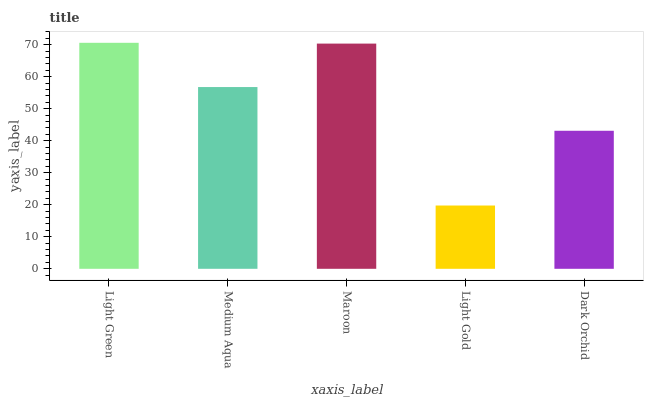Is Light Gold the minimum?
Answer yes or no. Yes. Is Light Green the maximum?
Answer yes or no. Yes. Is Medium Aqua the minimum?
Answer yes or no. No. Is Medium Aqua the maximum?
Answer yes or no. No. Is Light Green greater than Medium Aqua?
Answer yes or no. Yes. Is Medium Aqua less than Light Green?
Answer yes or no. Yes. Is Medium Aqua greater than Light Green?
Answer yes or no. No. Is Light Green less than Medium Aqua?
Answer yes or no. No. Is Medium Aqua the high median?
Answer yes or no. Yes. Is Medium Aqua the low median?
Answer yes or no. Yes. Is Light Green the high median?
Answer yes or no. No. Is Light Gold the low median?
Answer yes or no. No. 